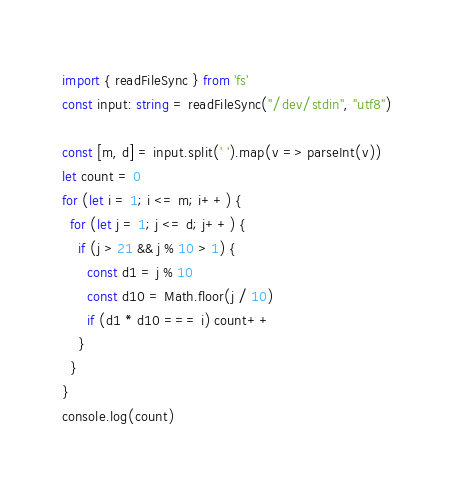Convert code to text. <code><loc_0><loc_0><loc_500><loc_500><_TypeScript_>import { readFileSync } from 'fs'
const input: string = readFileSync("/dev/stdin", "utf8")

const [m, d] = input.split(' ').map(v => parseInt(v))
let count = 0
for (let i = 1; i <= m; i++) {
  for (let j = 1; j <= d; j++) {
    if (j > 21 && j % 10 > 1) {
      const d1 = j % 10
      const d10 = Math.floor(j / 10)
      if (d1 * d10 === i) count++
    }
  }
}
console.log(count)</code> 